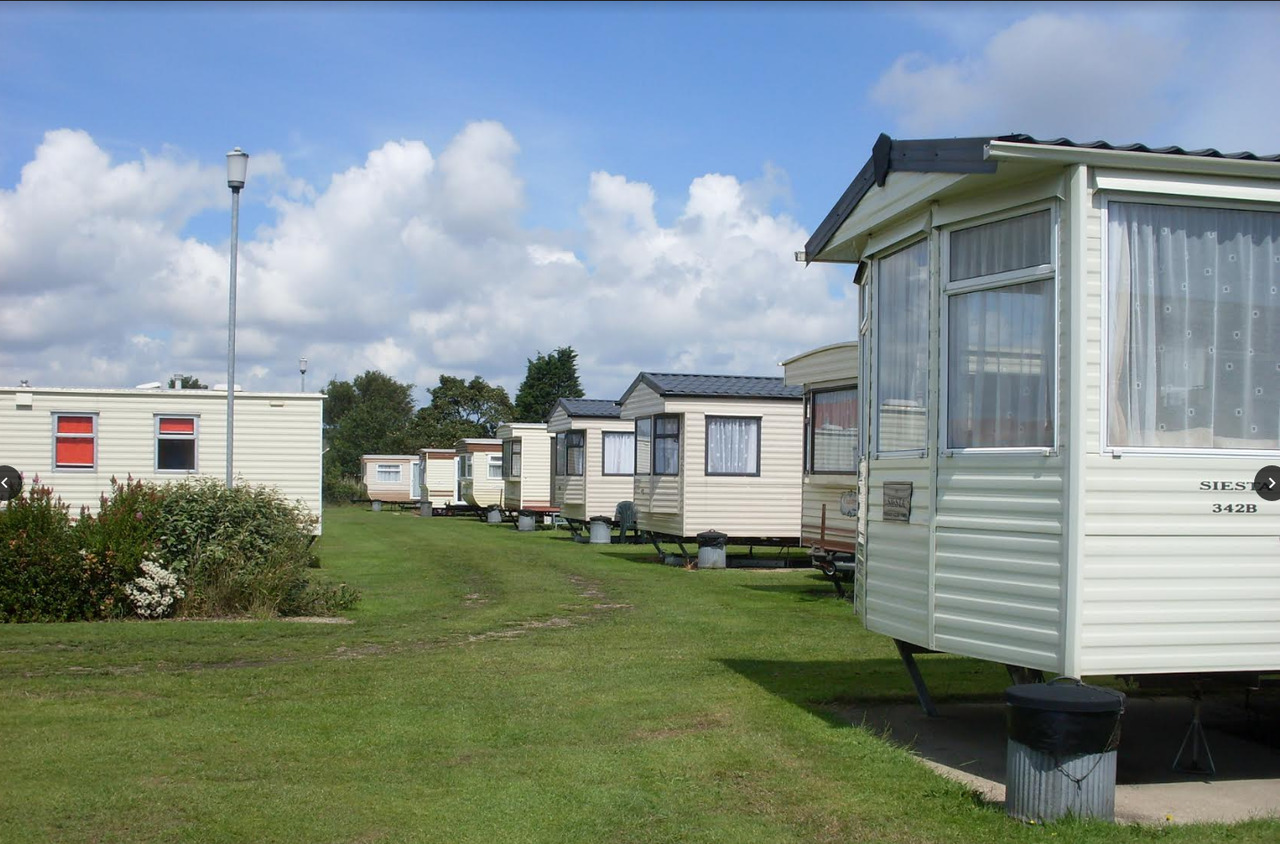What stories might the residents of these caravans share during communal gatherings? Residents might share stories of their travels and adventures, recounting scenic routes taken and the places they have visited. Stories of family traditions during holidays spent at the park, children's first steps, or learning to ride a bike on the park’s grass might evoke collective nostalgia. Tales of unusual incidents, surprise encounters, and emerging friendships formed over evening barbecues would be popular. Additionally, they might discuss the changes in the park over the years, reminiscing about old friends and seasons gone by. 